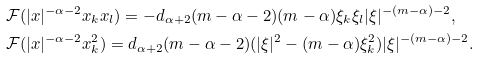<formula> <loc_0><loc_0><loc_500><loc_500>& \mathcal { F } ( | x | ^ { - \alpha - 2 } x _ { k } x _ { l } ) = - d _ { \alpha + 2 } ( m - \alpha - 2 ) ( m - \alpha ) \xi _ { k } \xi _ { l } | \xi | ^ { - ( m - \alpha ) - 2 } , \\ & \mathcal { F } ( | x | ^ { - \alpha - 2 } x _ { k } ^ { 2 } ) = d _ { \alpha + 2 } ( m - \alpha - 2 ) ( | \xi | ^ { 2 } - ( m - \alpha ) \xi _ { k } ^ { 2 } ) | \xi | ^ { - ( m - \alpha ) - 2 } .</formula> 